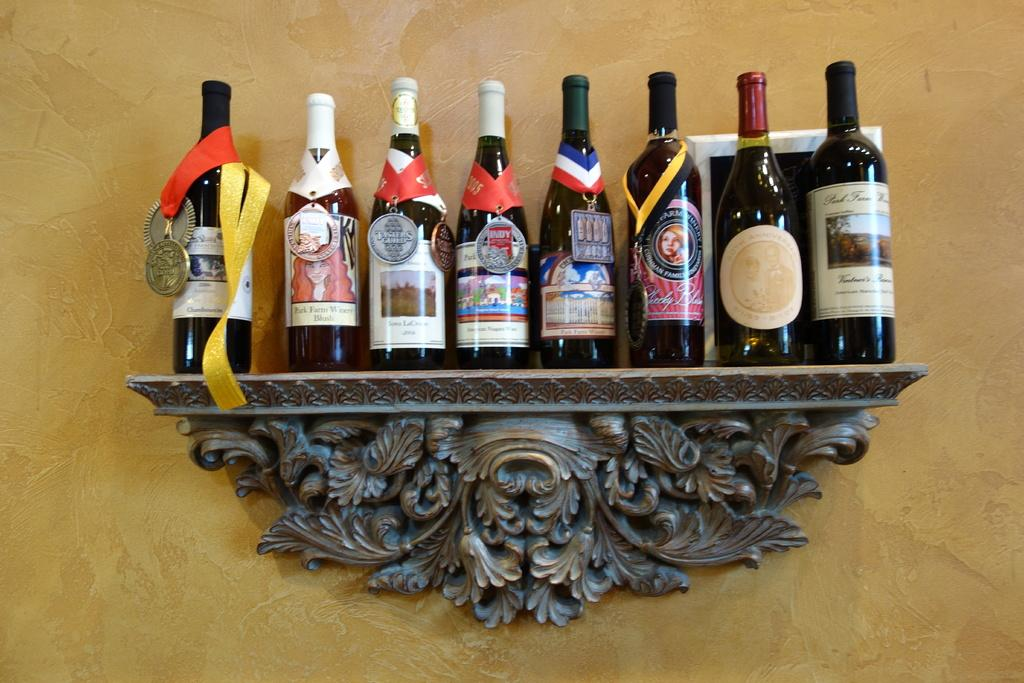What can be seen on the shelf in the image? There are wine bottles on a shelf in the image. Are there any distinguishing features on the wine bottles? Yes, a medal is present on one of the wine bottles. What is the color of the wall in the image? The wall in the image has a light yellow color. What type of coal is being used to fuel the fireplace in the image? There is no fireplace or coal present in the image; it features wine bottles on a shelf with a medal and a light yellow wall. 